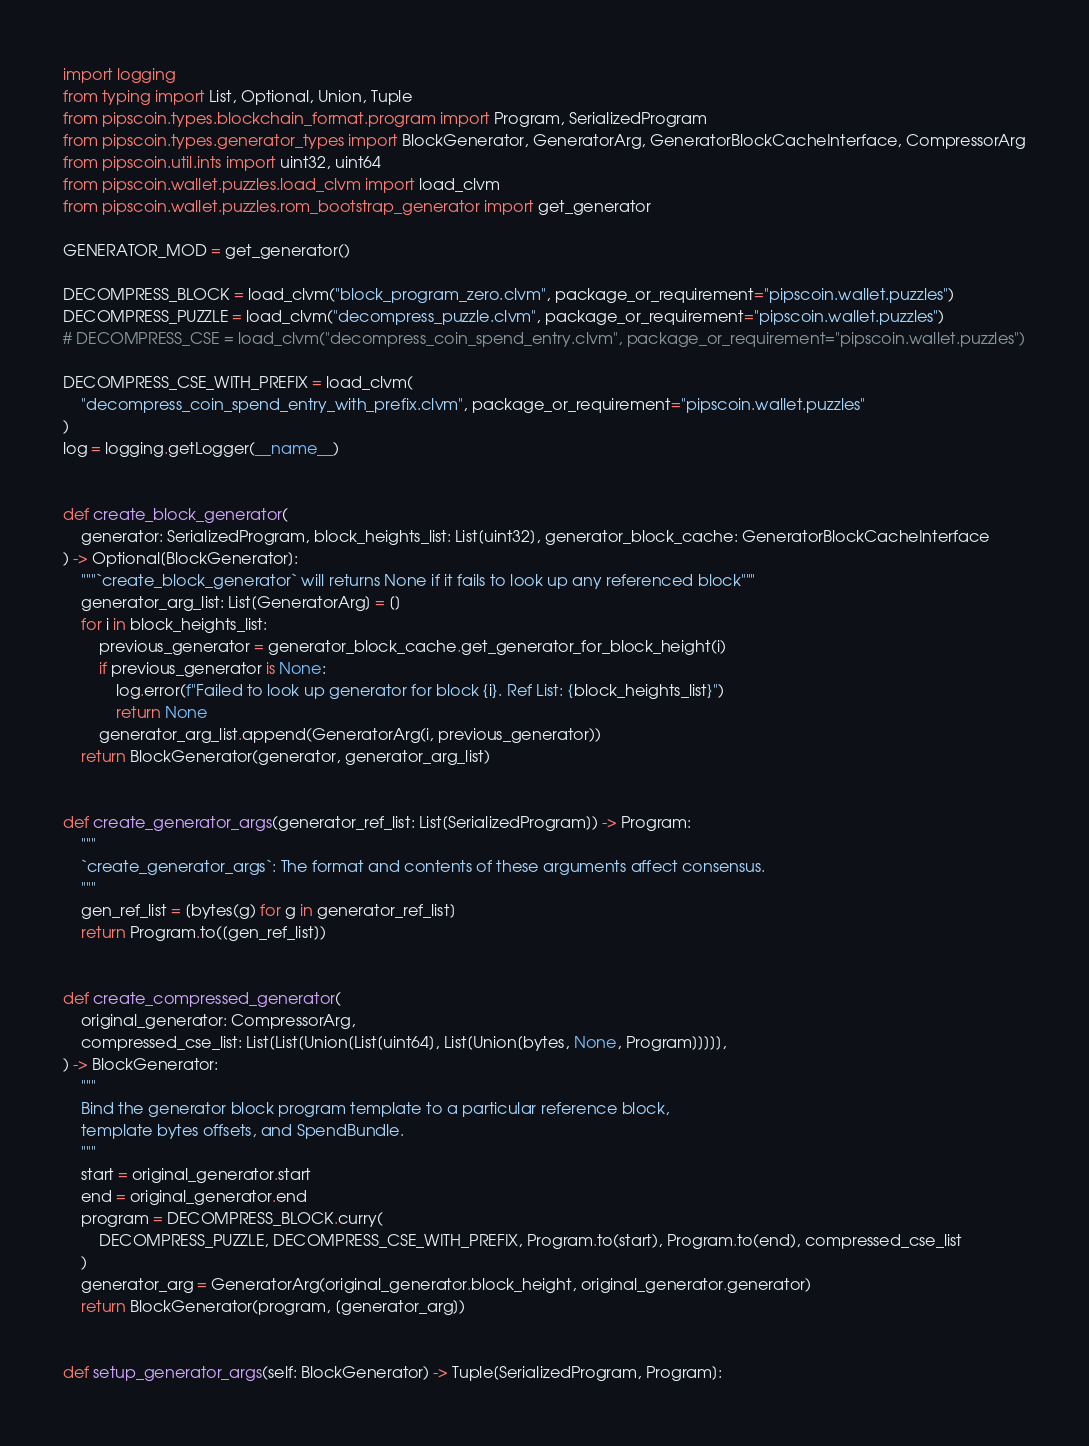<code> <loc_0><loc_0><loc_500><loc_500><_Python_>import logging
from typing import List, Optional, Union, Tuple
from pipscoin.types.blockchain_format.program import Program, SerializedProgram
from pipscoin.types.generator_types import BlockGenerator, GeneratorArg, GeneratorBlockCacheInterface, CompressorArg
from pipscoin.util.ints import uint32, uint64
from pipscoin.wallet.puzzles.load_clvm import load_clvm
from pipscoin.wallet.puzzles.rom_bootstrap_generator import get_generator

GENERATOR_MOD = get_generator()

DECOMPRESS_BLOCK = load_clvm("block_program_zero.clvm", package_or_requirement="pipscoin.wallet.puzzles")
DECOMPRESS_PUZZLE = load_clvm("decompress_puzzle.clvm", package_or_requirement="pipscoin.wallet.puzzles")
# DECOMPRESS_CSE = load_clvm("decompress_coin_spend_entry.clvm", package_or_requirement="pipscoin.wallet.puzzles")

DECOMPRESS_CSE_WITH_PREFIX = load_clvm(
    "decompress_coin_spend_entry_with_prefix.clvm", package_or_requirement="pipscoin.wallet.puzzles"
)
log = logging.getLogger(__name__)


def create_block_generator(
    generator: SerializedProgram, block_heights_list: List[uint32], generator_block_cache: GeneratorBlockCacheInterface
) -> Optional[BlockGenerator]:
    """`create_block_generator` will returns None if it fails to look up any referenced block"""
    generator_arg_list: List[GeneratorArg] = []
    for i in block_heights_list:
        previous_generator = generator_block_cache.get_generator_for_block_height(i)
        if previous_generator is None:
            log.error(f"Failed to look up generator for block {i}. Ref List: {block_heights_list}")
            return None
        generator_arg_list.append(GeneratorArg(i, previous_generator))
    return BlockGenerator(generator, generator_arg_list)


def create_generator_args(generator_ref_list: List[SerializedProgram]) -> Program:
    """
    `create_generator_args`: The format and contents of these arguments affect consensus.
    """
    gen_ref_list = [bytes(g) for g in generator_ref_list]
    return Program.to([gen_ref_list])


def create_compressed_generator(
    original_generator: CompressorArg,
    compressed_cse_list: List[List[Union[List[uint64], List[Union[bytes, None, Program]]]]],
) -> BlockGenerator:
    """
    Bind the generator block program template to a particular reference block,
    template bytes offsets, and SpendBundle.
    """
    start = original_generator.start
    end = original_generator.end
    program = DECOMPRESS_BLOCK.curry(
        DECOMPRESS_PUZZLE, DECOMPRESS_CSE_WITH_PREFIX, Program.to(start), Program.to(end), compressed_cse_list
    )
    generator_arg = GeneratorArg(original_generator.block_height, original_generator.generator)
    return BlockGenerator(program, [generator_arg])


def setup_generator_args(self: BlockGenerator) -> Tuple[SerializedProgram, Program]:</code> 